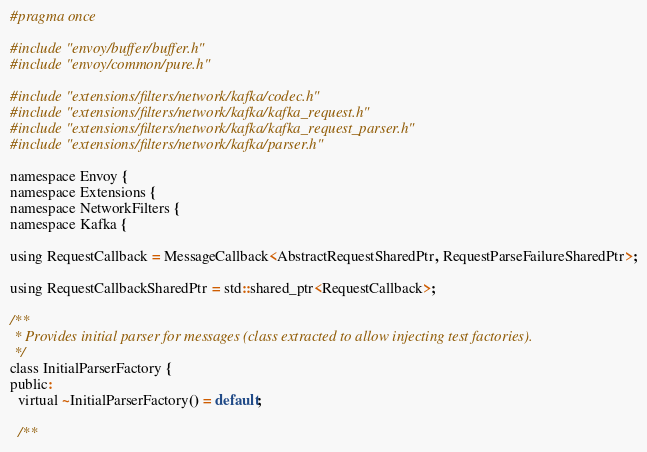Convert code to text. <code><loc_0><loc_0><loc_500><loc_500><_C_>#pragma once

#include "envoy/buffer/buffer.h"
#include "envoy/common/pure.h"

#include "extensions/filters/network/kafka/codec.h"
#include "extensions/filters/network/kafka/kafka_request.h"
#include "extensions/filters/network/kafka/kafka_request_parser.h"
#include "extensions/filters/network/kafka/parser.h"

namespace Envoy {
namespace Extensions {
namespace NetworkFilters {
namespace Kafka {

using RequestCallback = MessageCallback<AbstractRequestSharedPtr, RequestParseFailureSharedPtr>;

using RequestCallbackSharedPtr = std::shared_ptr<RequestCallback>;

/**
 * Provides initial parser for messages (class extracted to allow injecting test factories).
 */
class InitialParserFactory {
public:
  virtual ~InitialParserFactory() = default;

  /**</code> 